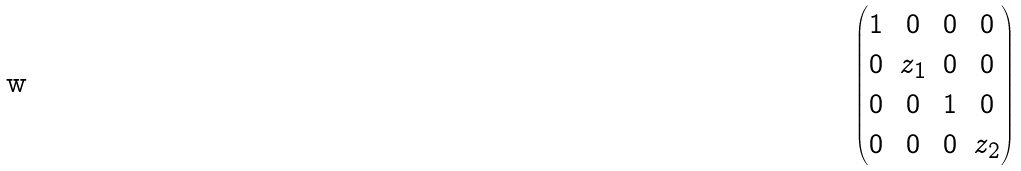<formula> <loc_0><loc_0><loc_500><loc_500>\begin{pmatrix} 1 & 0 & 0 & 0 \\ 0 & z _ { 1 } & 0 & 0 \\ 0 & 0 & 1 & 0 \\ 0 & 0 & 0 & z _ { 2 } \end{pmatrix}</formula> 